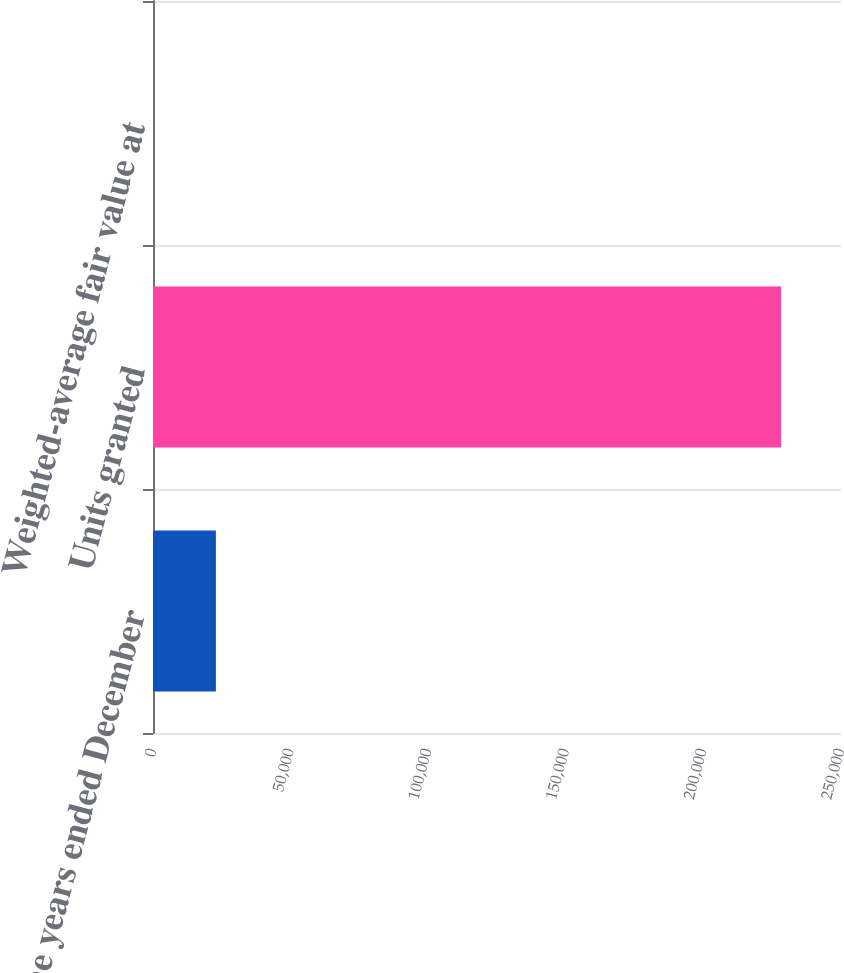<chart> <loc_0><loc_0><loc_500><loc_500><bar_chart><fcel>For the years ended December<fcel>Units granted<fcel>Weighted-average fair value at<nl><fcel>22852.2<fcel>228224<fcel>33.17<nl></chart> 